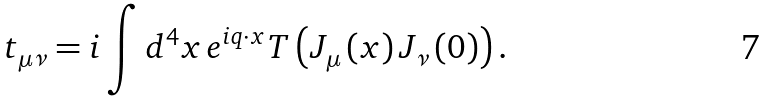Convert formula to latex. <formula><loc_0><loc_0><loc_500><loc_500>t _ { \mu \nu } = i \int d ^ { 4 } x \, e ^ { i q \cdot x } T \left ( J _ { \mu } \left ( x \right ) J _ { \nu } \left ( 0 \right ) \right ) .</formula> 